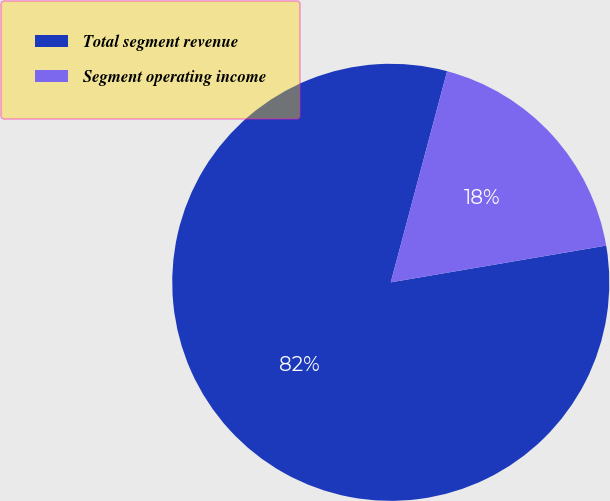Convert chart. <chart><loc_0><loc_0><loc_500><loc_500><pie_chart><fcel>Total segment revenue<fcel>Segment operating income<nl><fcel>81.84%<fcel>18.16%<nl></chart> 